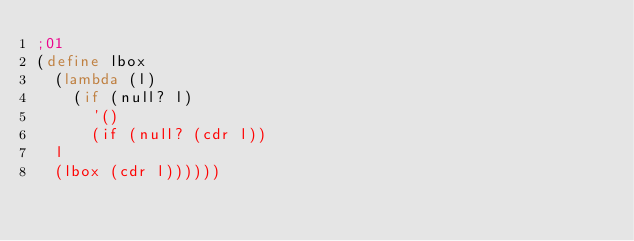<code> <loc_0><loc_0><loc_500><loc_500><_Scheme_>;01
(define lbox
  (lambda (l)
    (if (null? l) 
      '()
      (if (null? (cdr l))
	l
	(lbox (cdr l))))))

</code> 